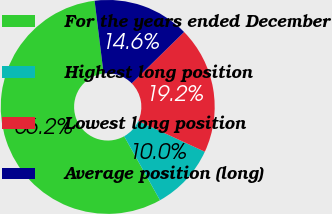Convert chart. <chart><loc_0><loc_0><loc_500><loc_500><pie_chart><fcel>For the years ended December<fcel>Highest long position<fcel>Lowest long position<fcel>Average position (long)<nl><fcel>56.17%<fcel>9.99%<fcel>19.23%<fcel>14.61%<nl></chart> 